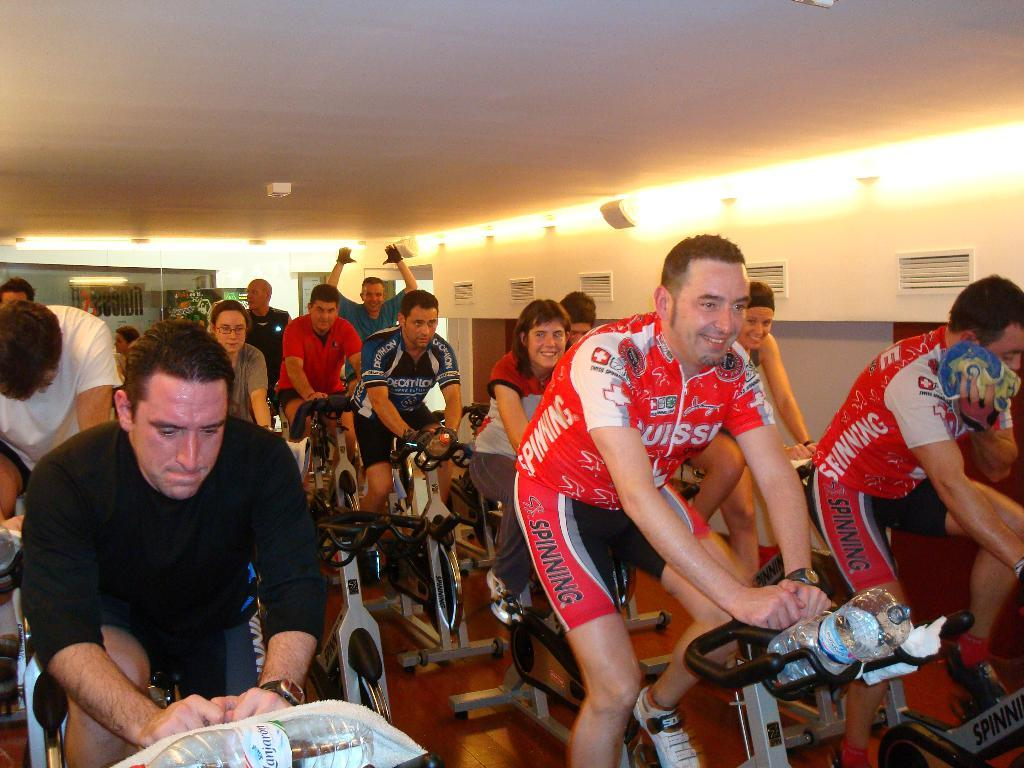What are the people in the foreground of the image doing? The people in the foreground of the image are cycling on gym cycles. What objects can be seen in the image besides the gym cycles? There are bottles and clothes visible in the image. What can be seen in the background of the image? In the background of the image, there is a ceiling, lights, and a wall. What type of punishment is being administered to the people cycling in the image? There is no punishment being administered to the people cycling in the image; they are exercising on gym cycles. What color is the sheet draped over the wall in the background of the image? There is no sheet visible in the image; only a wall is present in the background. 